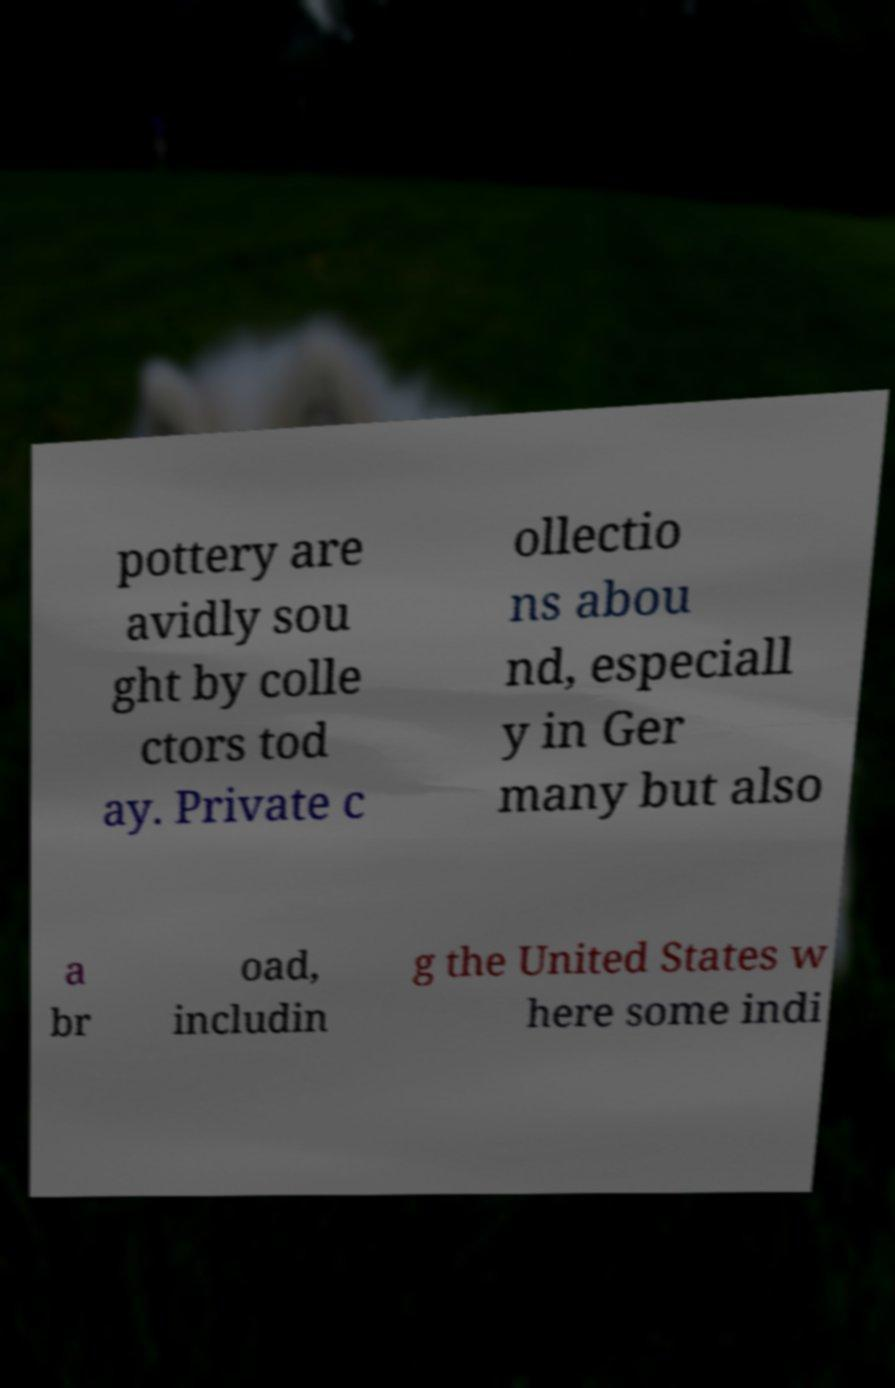Please read and relay the text visible in this image. What does it say? pottery are avidly sou ght by colle ctors tod ay. Private c ollectio ns abou nd, especiall y in Ger many but also a br oad, includin g the United States w here some indi 